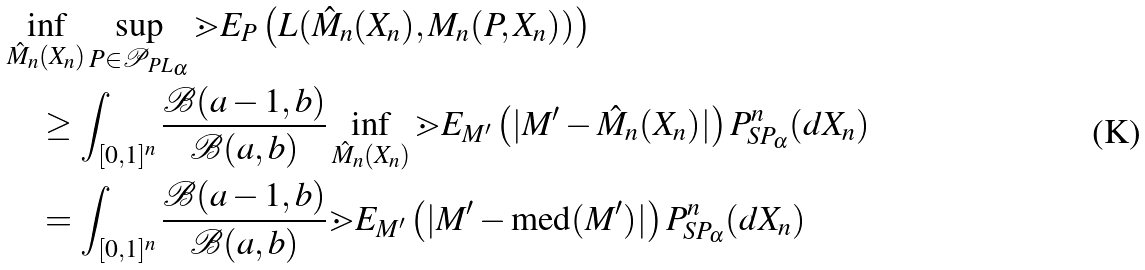<formula> <loc_0><loc_0><loc_500><loc_500>& \inf _ { \hat { M } _ { n } ( X _ { n } ) } \sup _ { P \in \mathcal { P } _ { P L _ { \alpha } } } \mathbb { m } { E } _ { P } \left ( L ( \hat { M } _ { n } ( X _ { n } ) , M _ { n } ( P , X _ { n } ) ) \right ) \\ & \quad \geq \int _ { [ 0 , 1 ] ^ { n } } \frac { \mathcal { B } ( a - 1 , b ) } { \mathcal { B } ( a , b ) } \inf _ { \hat { M } _ { n } ( X _ { n } ) } \mathbb { m } { E } _ { M ^ { \prime } } \left ( | M ^ { \prime } - \hat { M } _ { n } ( X _ { n } ) | \right ) P ^ { n } _ { S P _ { \alpha } } ( d X _ { n } ) \\ & \quad = \int _ { [ 0 , 1 ] ^ { n } } \frac { \mathcal { B } ( a - 1 , b ) } { \mathcal { B } ( a , b ) } \mathbb { m } { E } _ { M ^ { \prime } } \left ( | M ^ { \prime } - \text {med} ( M ^ { \prime } ) | \right ) P ^ { n } _ { S P _ { \alpha } } ( d X _ { n } )</formula> 